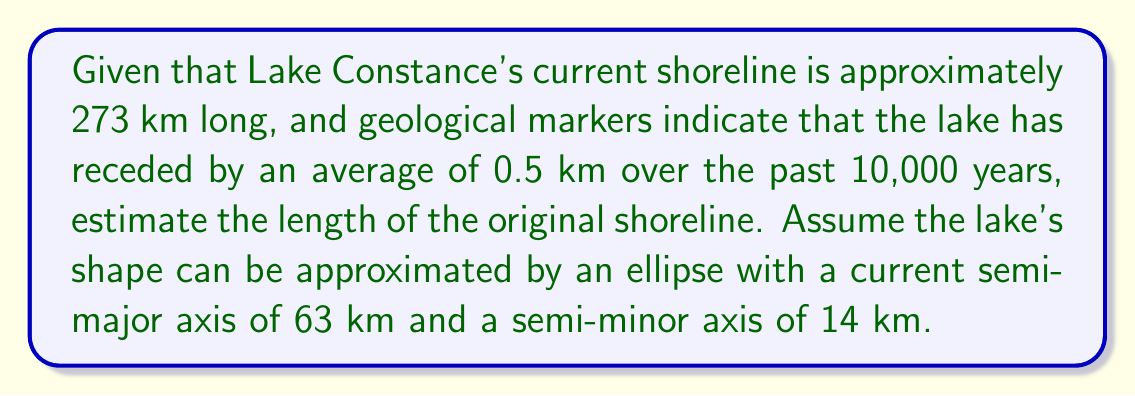Can you solve this math problem? To solve this problem, we'll follow these steps:

1. Calculate the current perimeter of the lake using the ellipse formula:
   $$P \approx 2\pi\sqrt{\frac{a^2 + b^2}{2}}$$
   where $a$ is the semi-major axis and $b$ is the semi-minor axis.

2. Determine the scaling factor to adjust our calculated perimeter to the actual shoreline length.

3. Calculate the original semi-major and semi-minor axes by adding the recession distance.

4. Use the ellipse formula with the original axes to estimate the original shoreline length.

Step 1: Current perimeter calculation
$$P \approx 2\pi\sqrt{\frac{63^2 + 14^2}{2}} \approx 280.76 \text{ km}$$

Step 2: Scaling factor
Actual shoreline / Calculated perimeter = $273 / 280.76 \approx 0.9724$

Step 3: Original axes
Original semi-major axis: $63 + 0.5 = 63.5 \text{ km}$
Original semi-minor axis: $14 + 0.5 = 14.5 \text{ km}$

Step 4: Original shoreline estimation
$$P_{original} \approx 2\pi\sqrt{\frac{63.5^2 + 14.5^2}{2}} \approx 283.65 \text{ km}$$

Applying the scaling factor:
$283.65 \times 0.9724 \approx 275.82 \text{ km}$

Therefore, the estimated original shoreline length is approximately 275.82 km.
Answer: 275.82 km 